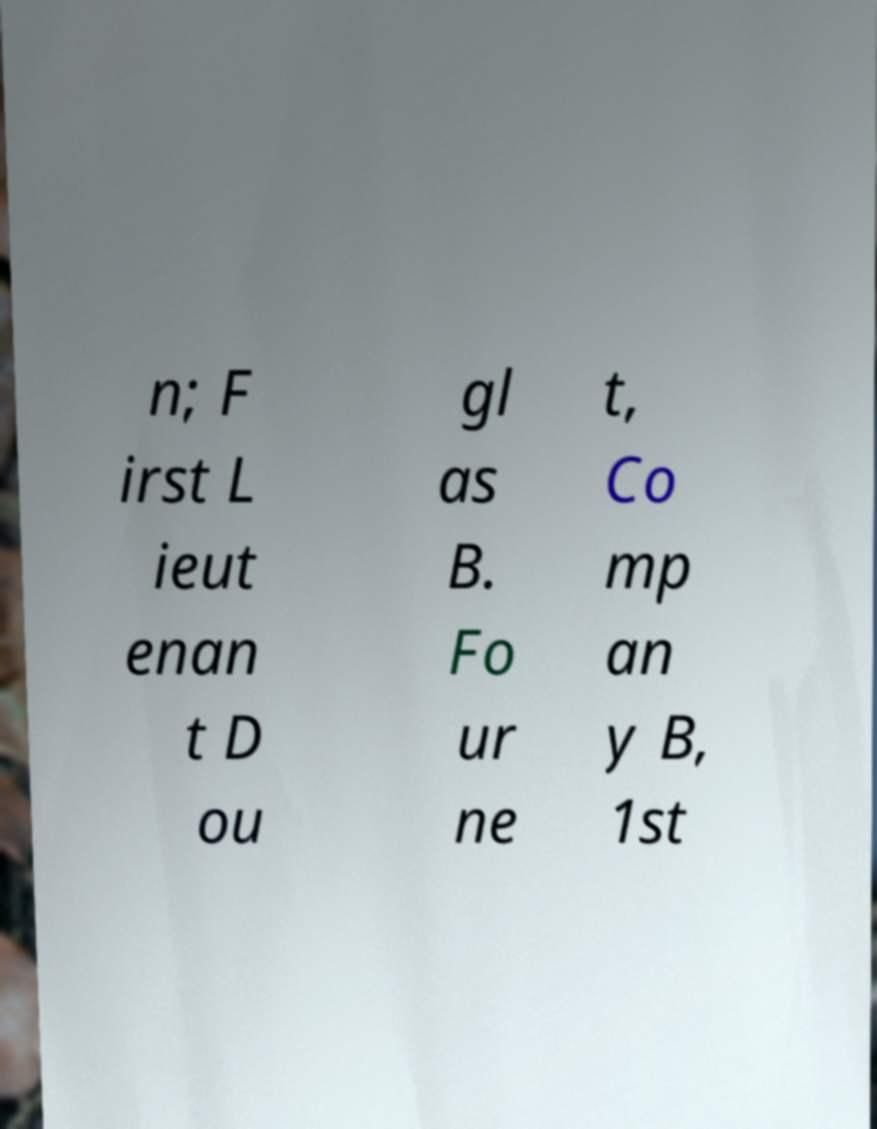Could you extract and type out the text from this image? n; F irst L ieut enan t D ou gl as B. Fo ur ne t, Co mp an y B, 1st 